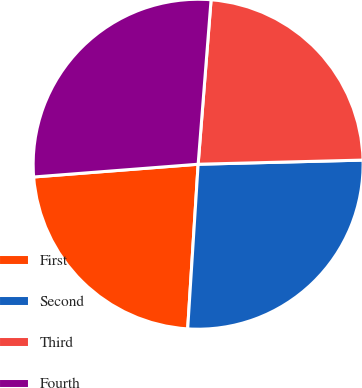Convert chart. <chart><loc_0><loc_0><loc_500><loc_500><pie_chart><fcel>First<fcel>Second<fcel>Third<fcel>Fourth<nl><fcel>22.76%<fcel>26.41%<fcel>23.35%<fcel>27.48%<nl></chart> 